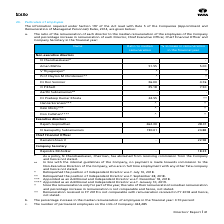According to Tata Consultancy Services's financial document, Which Director had the highest % increase in remuneration in the financial year? According to the financial document, Rajesh Gopinathan. The relevant text states: "Rajesh Gopinathan 262.30 28.31..." Also, Why was the remuneration for N Chandrasekaran not stated? As a policy, N Chandrasekaran, Chairman, has abstained from receiving commission from the Company and hence not stated.. The document states: "@ As a policy, N Chandrasekaran, Chairman, has abstained from receiving commission from the Company and hence not stated. @@ In line with the internal..." Also, can you calculate: What is the difference between the percentage increase in the median remuneration of employees and managerial remuneration for the financial year? Based on the calculation: 14.66 - 3.70 , the result is 10.96 (percentage). This is based on the information: "remuneration of employees in the financial year: 3.70 percent..." The key data points involved are: 14.66, 3.70. Also, can you calculate: What is the average % increase in remuneration in the financial year for the Director, Chief Executive Officer, Chief Financial Officer and Company Secretary? To answer this question, I need to perform calculations using the financial data. The calculation is: (5.00 + 4.76 + 7.50 + 28.31 + 24.88 + 22.58 + 18.23)/7 , which equals 15.89 (percentage). This is based on the information: "Aman Mehta 51.55 5.00 O P Bhatt 35.18 7.50 Ramakrishnan V - 22.58 Rajesh Gopinathan 262.30 28.31 N Ganapathy Subramaniam 190.01 24.88 Rajendra Moholkar - 18.23 Dr Ron Sommer 36.00 4.76..." The key data points involved are: 18.23, 22.58, 24.88. Also, can you calculate: What is the difference in ratio to median remuneration between the two Executive Directors? Based on the calculation: 262.30 - 190.01 , the result is 72.29. This is based on the information: "N Ganapathy Subramaniam 190.01 24.88 Rajesh Gopinathan 262.30 28.31..." The key data points involved are: 190.01, 262.30. Also, What information does the second table column provide? The ratio of the remuneration of each director to the median remuneration of the employees of the Company. The document states: "a. The ratio of the remuneration of each director to the median remuneration of the employees of the Company and percentage increase in remuneration o..." 